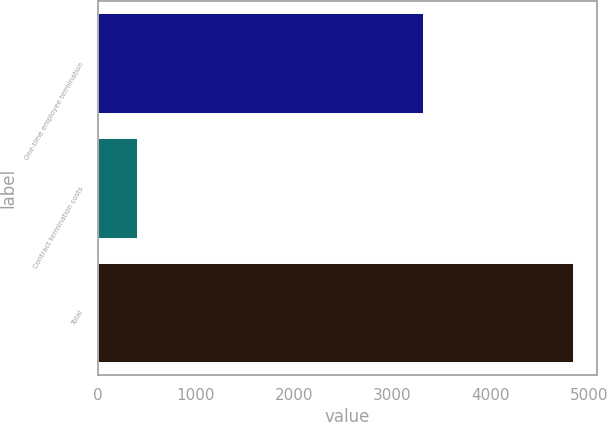Convert chart to OTSL. <chart><loc_0><loc_0><loc_500><loc_500><bar_chart><fcel>One-time employee termination<fcel>Contract termination costs<fcel>Total<nl><fcel>3313<fcel>405<fcel>4836<nl></chart> 